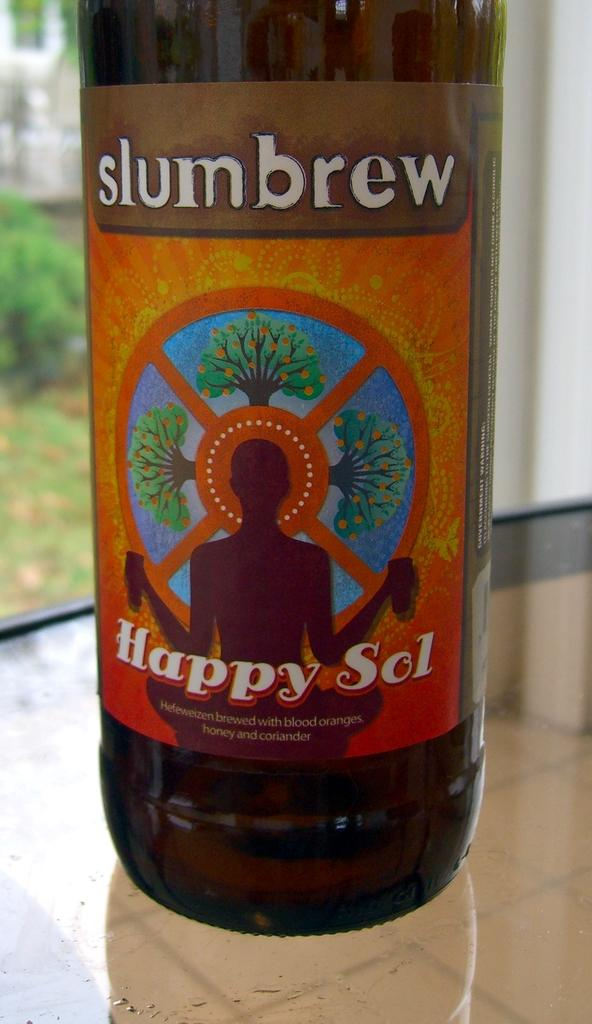What piece of furniture is present in the image? There is a table in the image. What object is placed on the table? There is a bottle on the table. Can you describe the background of the image? The background of the image is blurred. What type of dress is the chair wearing in the image? There is no chair or dress present in the image. How is the bottle being measured in the image? The image does not show any measuring of the bottle. 